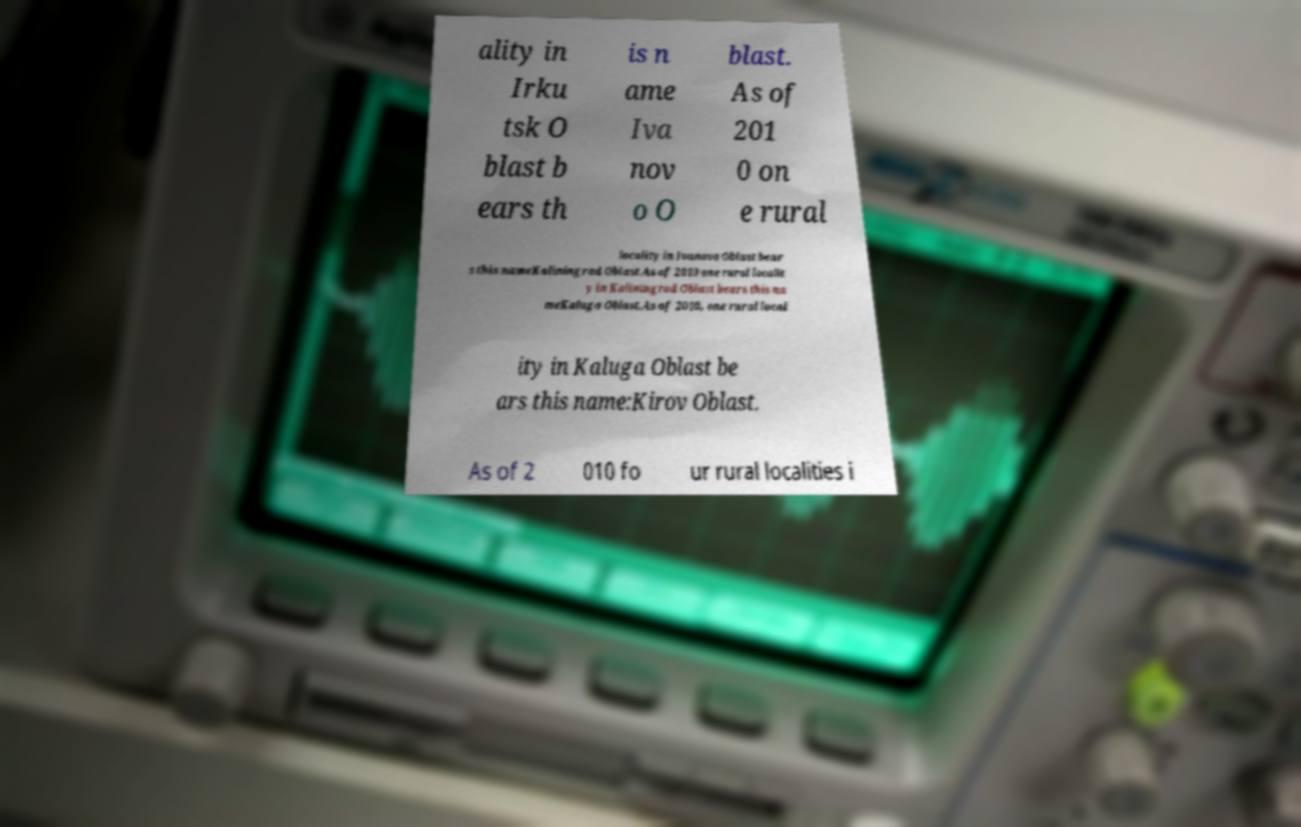There's text embedded in this image that I need extracted. Can you transcribe it verbatim? ality in Irku tsk O blast b ears th is n ame Iva nov o O blast. As of 201 0 on e rural locality in Ivanovo Oblast bear s this nameKaliningrad Oblast.As of 2010 one rural localit y in Kaliningrad Oblast bears this na meKaluga Oblast.As of 2010, one rural local ity in Kaluga Oblast be ars this name:Kirov Oblast. As of 2 010 fo ur rural localities i 